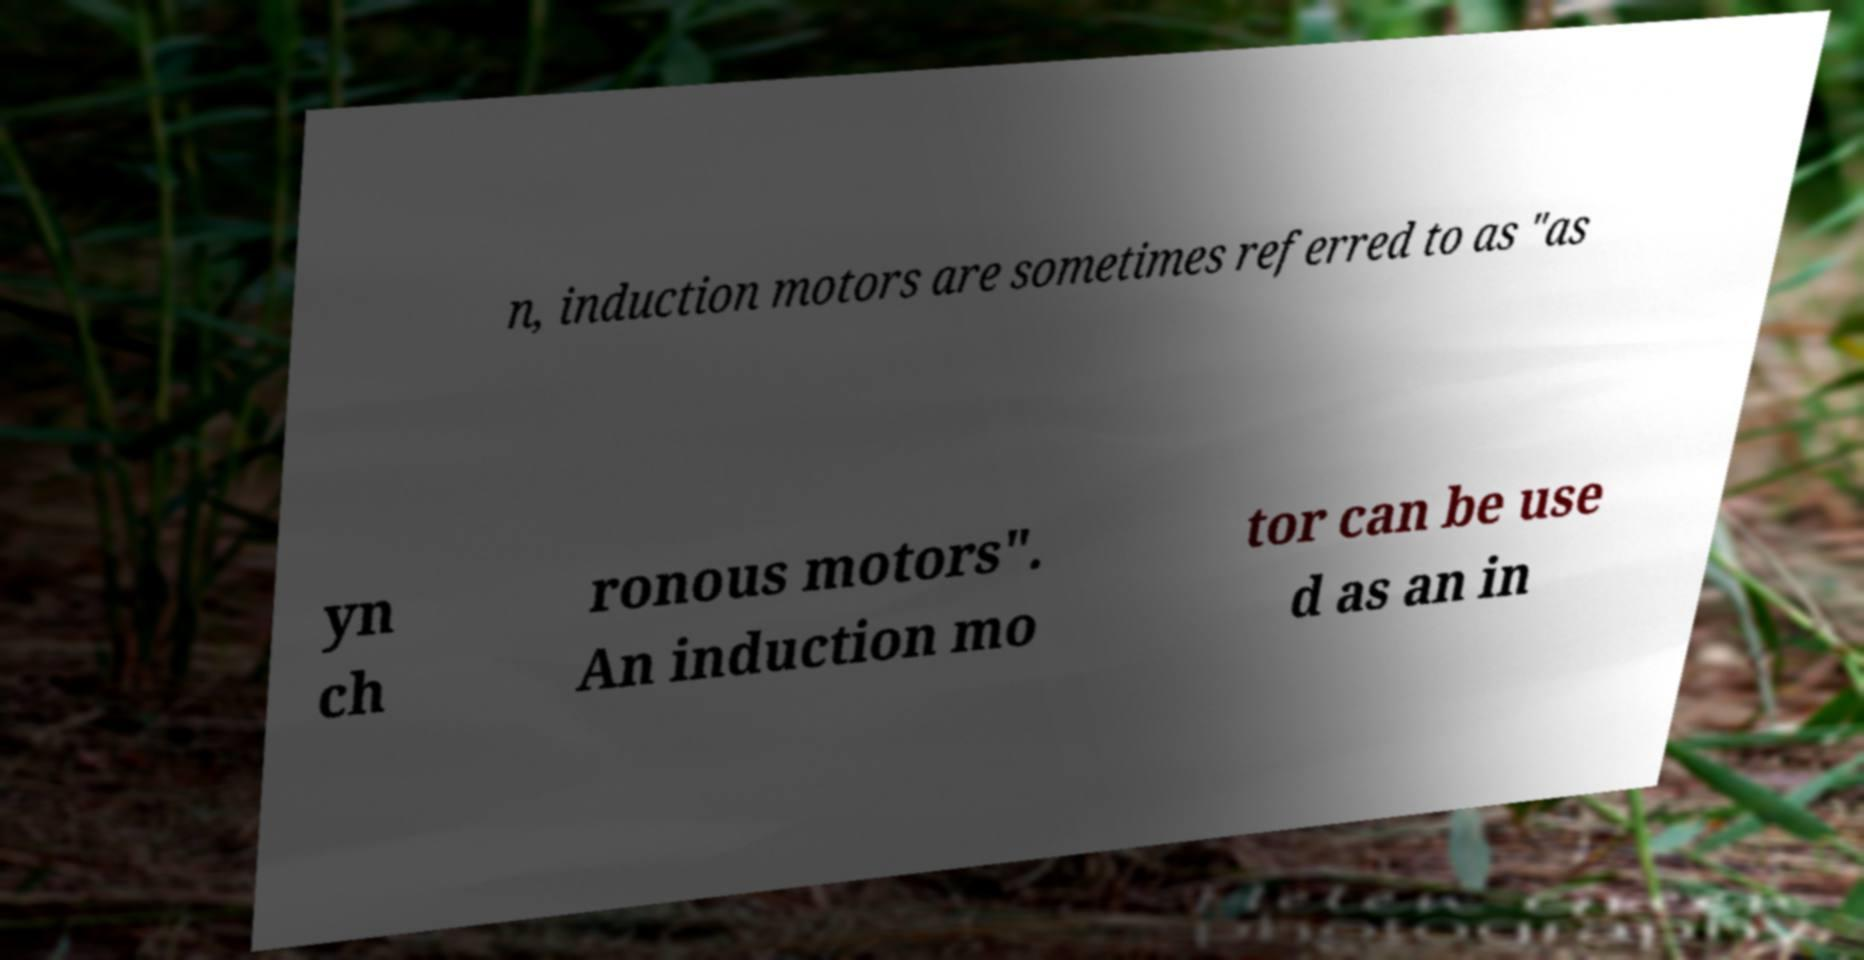Can you read and provide the text displayed in the image?This photo seems to have some interesting text. Can you extract and type it out for me? n, induction motors are sometimes referred to as "as yn ch ronous motors". An induction mo tor can be use d as an in 